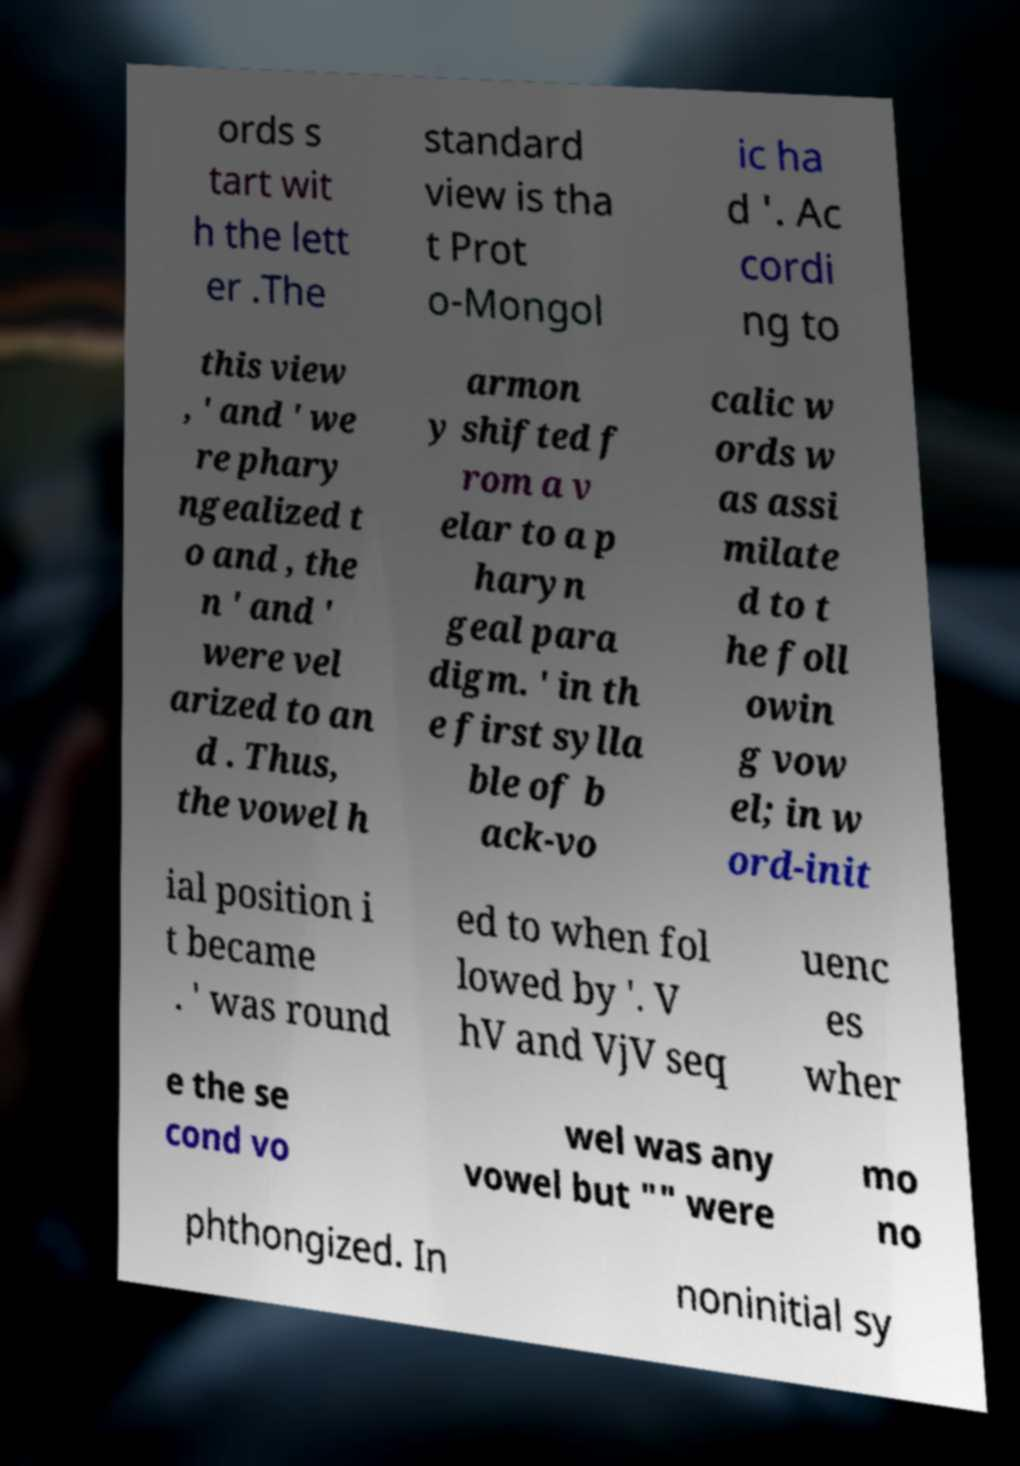There's text embedded in this image that I need extracted. Can you transcribe it verbatim? ords s tart wit h the lett er .The standard view is tha t Prot o-Mongol ic ha d '. Ac cordi ng to this view , ' and ' we re phary ngealized t o and , the n ' and ' were vel arized to an d . Thus, the vowel h armon y shifted f rom a v elar to a p haryn geal para digm. ' in th e first sylla ble of b ack-vo calic w ords w as assi milate d to t he foll owin g vow el; in w ord-init ial position i t became . ' was round ed to when fol lowed by '. V hV and VjV seq uenc es wher e the se cond vo wel was any vowel but "" were mo no phthongized. In noninitial sy 